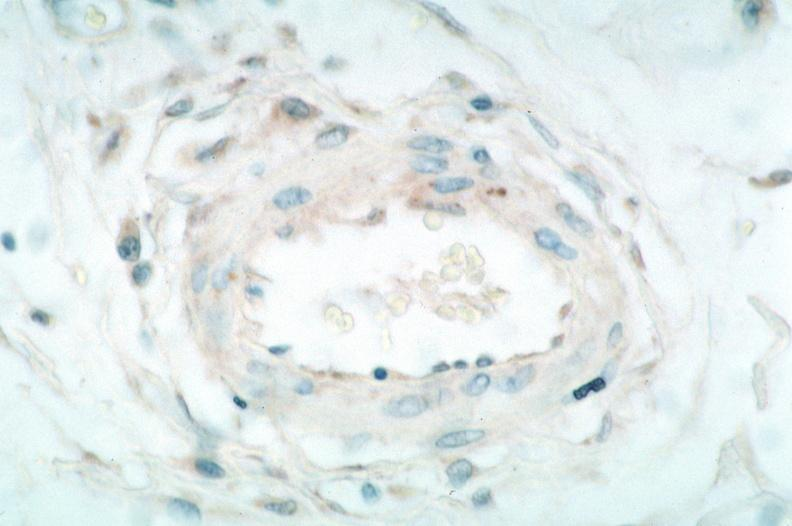s vasculature present?
Answer the question using a single word or phrase. Yes 